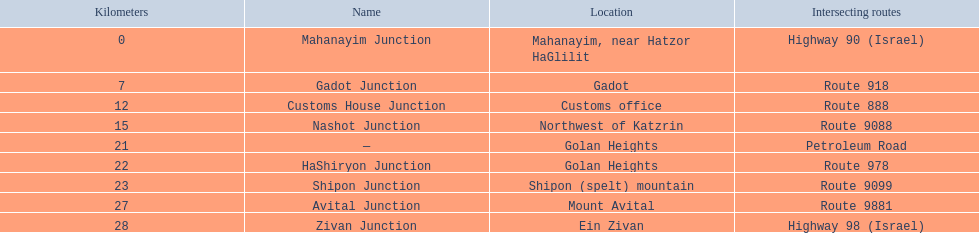How many different routes come across highway 91? 9. 